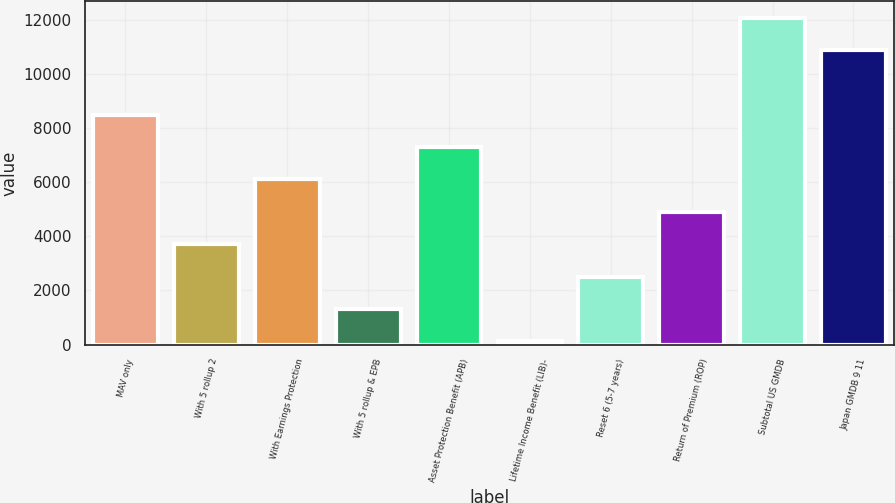Convert chart to OTSL. <chart><loc_0><loc_0><loc_500><loc_500><bar_chart><fcel>MAV only<fcel>With 5 rollup 2<fcel>With Earnings Protection<fcel>With 5 rollup & EPB<fcel>Asset Protection Benefit (APB)<fcel>Lifetime Income Benefit (LIB)-<fcel>Reset 6 (5-7 years)<fcel>Return of Premium (ROP)<fcel>Subtotal US GMDB<fcel>Japan GMDB 9 11<nl><fcel>8485<fcel>3705<fcel>6095<fcel>1315<fcel>7290<fcel>120<fcel>2510<fcel>4900<fcel>12070<fcel>10875<nl></chart> 